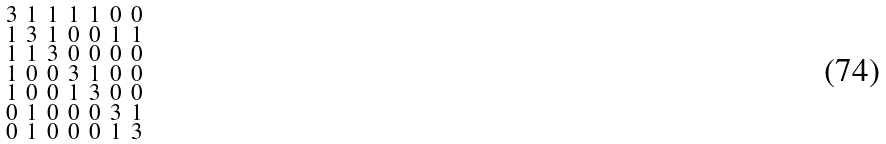Convert formula to latex. <formula><loc_0><loc_0><loc_500><loc_500>\begin{smallmatrix} 3 & 1 & 1 & 1 & 1 & 0 & 0 \\ 1 & 3 & 1 & 0 & 0 & 1 & 1 \\ 1 & 1 & 3 & 0 & 0 & 0 & 0 \\ 1 & 0 & 0 & 3 & 1 & 0 & 0 \\ 1 & 0 & 0 & 1 & 3 & 0 & 0 \\ 0 & 1 & 0 & 0 & 0 & 3 & 1 \\ 0 & 1 & 0 & 0 & 0 & 1 & 3 \end{smallmatrix}</formula> 